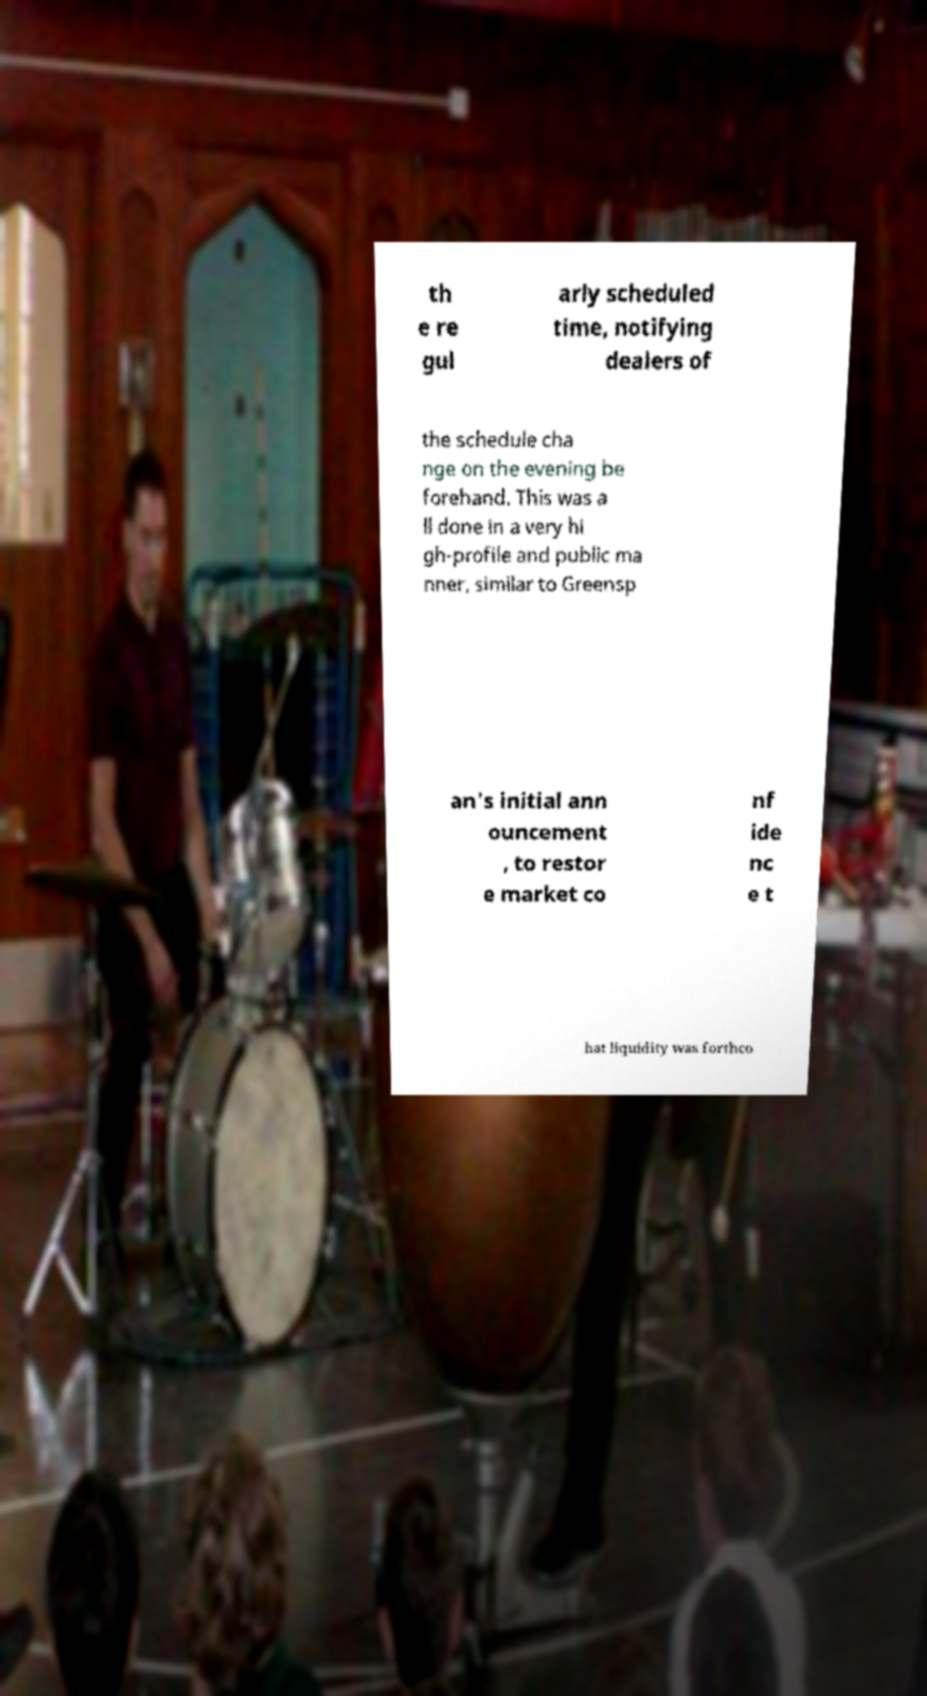I need the written content from this picture converted into text. Can you do that? th e re gul arly scheduled time, notifying dealers of the schedule cha nge on the evening be forehand. This was a ll done in a very hi gh-profile and public ma nner, similar to Greensp an's initial ann ouncement , to restor e market co nf ide nc e t hat liquidity was forthco 